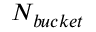<formula> <loc_0><loc_0><loc_500><loc_500>N _ { b u c k e t }</formula> 